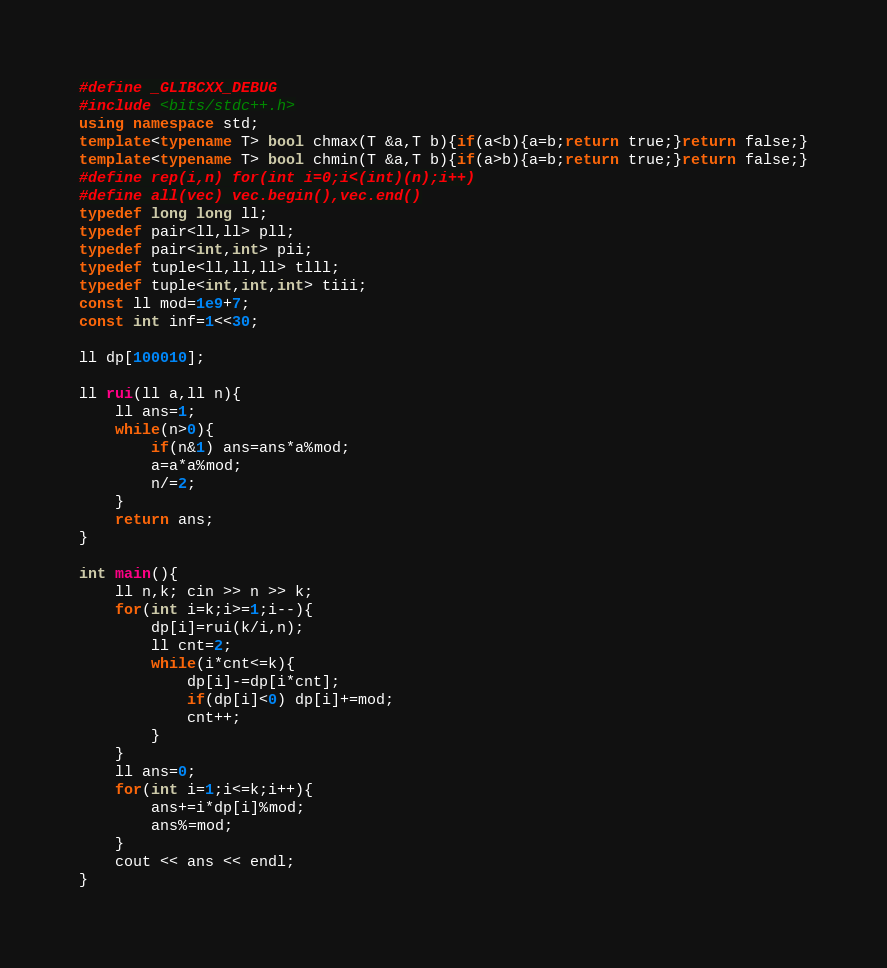<code> <loc_0><loc_0><loc_500><loc_500><_C++_>#define _GLIBCXX_DEBUG
#include <bits/stdc++.h>
using namespace std;
template<typename T> bool chmax(T &a,T b){if(a<b){a=b;return true;}return false;}
template<typename T> bool chmin(T &a,T b){if(a>b){a=b;return true;}return false;}
#define rep(i,n) for(int i=0;i<(int)(n);i++)
#define all(vec) vec.begin(),vec.end()
typedef long long ll;
typedef pair<ll,ll> pll;
typedef pair<int,int> pii;
typedef tuple<ll,ll,ll> tlll;
typedef tuple<int,int,int> tiii;
const ll mod=1e9+7;
const int inf=1<<30;

ll dp[100010];

ll rui(ll a,ll n){
	ll ans=1;
	while(n>0){
		if(n&1) ans=ans*a%mod;
		a=a*a%mod;
		n/=2;
	}
	return ans;
}

int main(){
	ll n,k; cin >> n >> k;
	for(int i=k;i>=1;i--){
		dp[i]=rui(k/i,n);
		ll cnt=2;
		while(i*cnt<=k){
			dp[i]-=dp[i*cnt];
			if(dp[i]<0) dp[i]+=mod;
			cnt++;
		}
	}
	ll ans=0;
	for(int i=1;i<=k;i++){
		ans+=i*dp[i]%mod;
		ans%=mod;
	}
	cout << ans << endl;
}</code> 